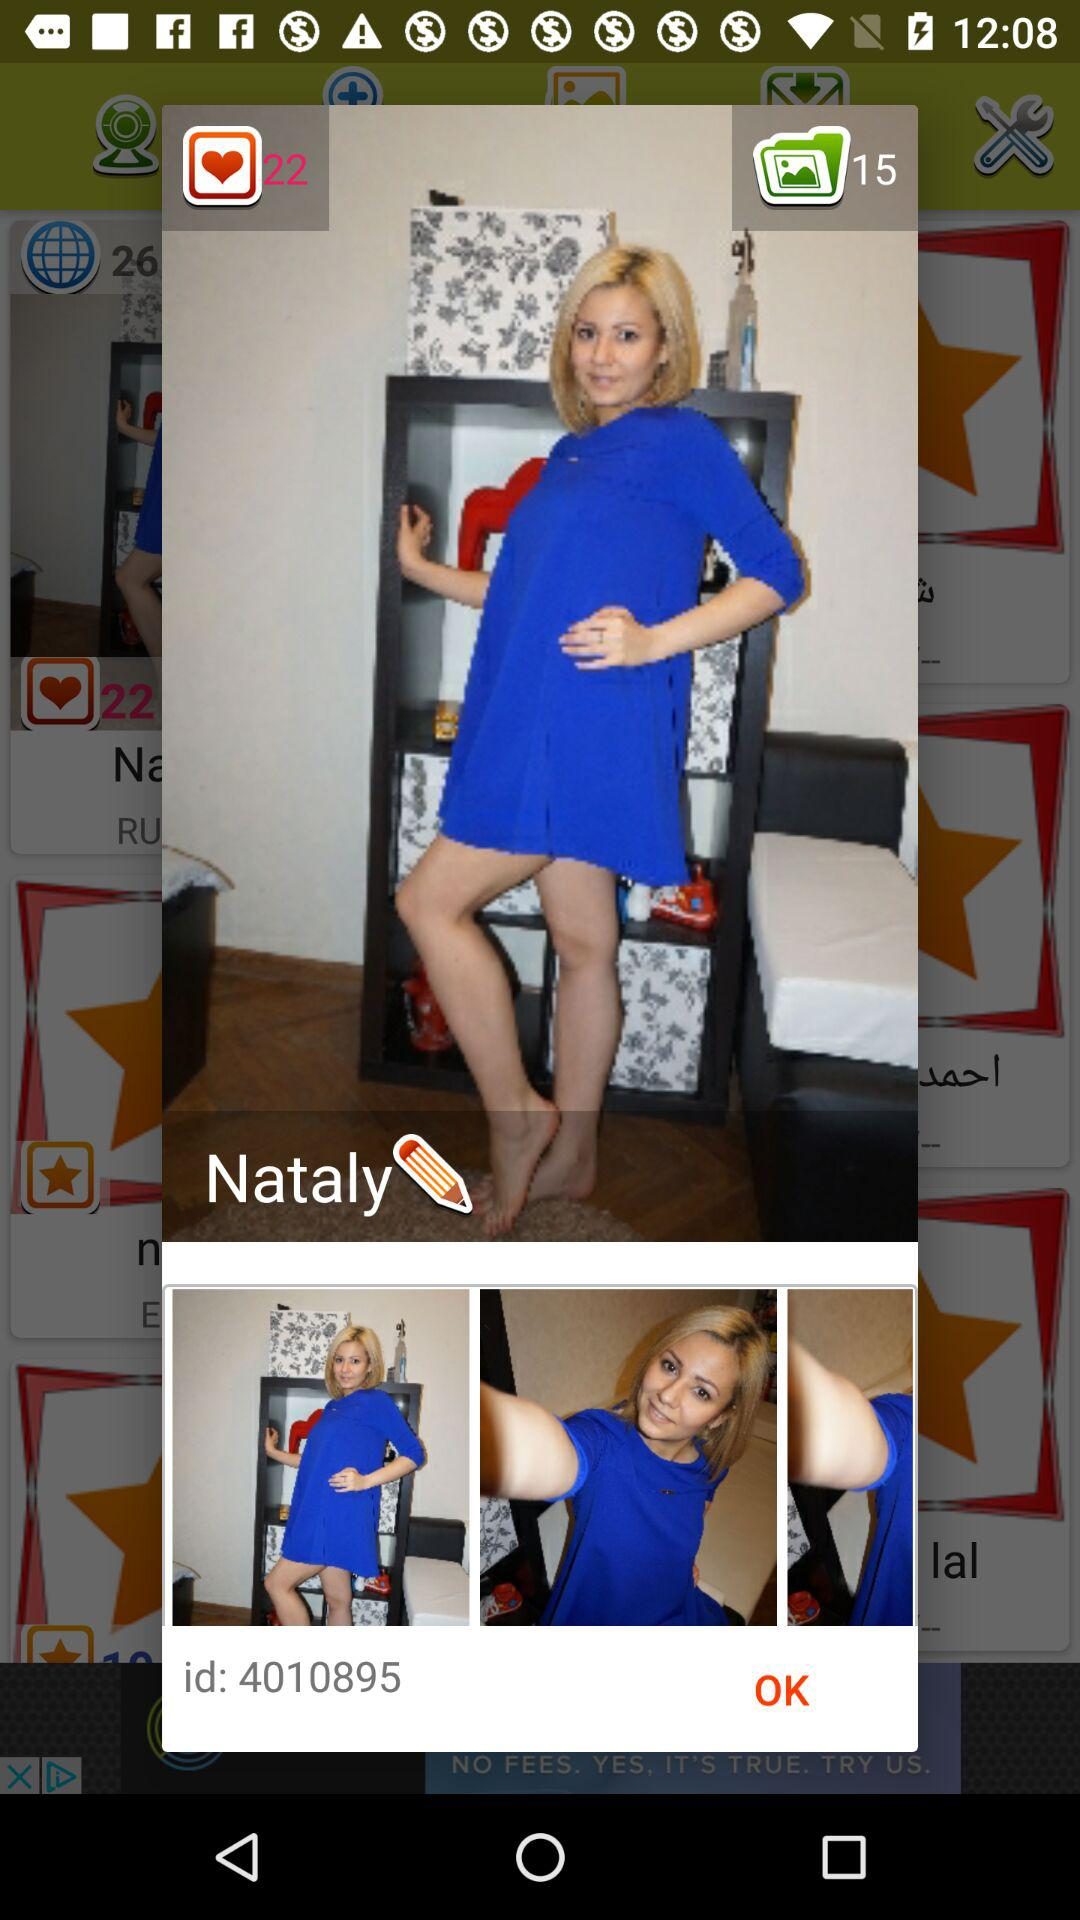What is the total number of images in the image folder? The total number of images in the image folder is 15. 